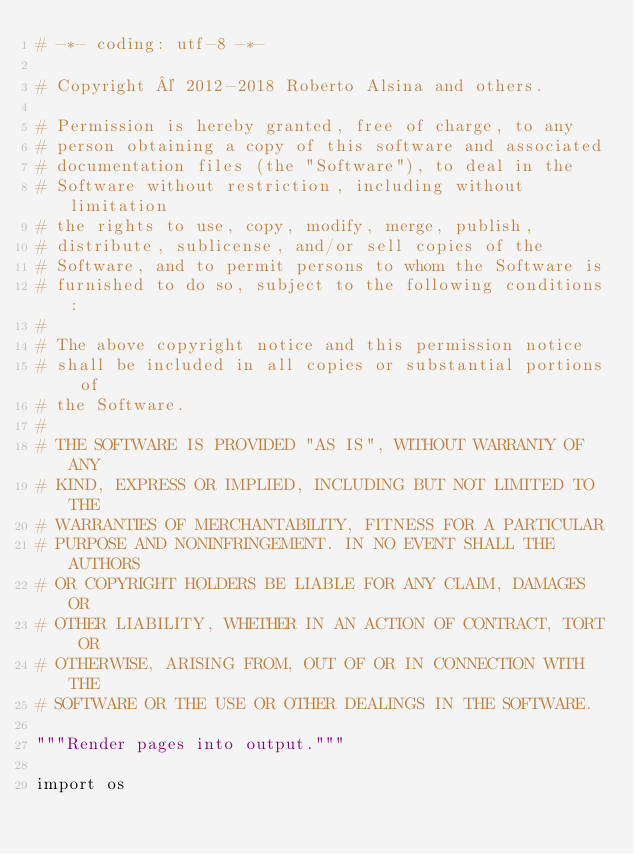<code> <loc_0><loc_0><loc_500><loc_500><_Python_># -*- coding: utf-8 -*-

# Copyright © 2012-2018 Roberto Alsina and others.

# Permission is hereby granted, free of charge, to any
# person obtaining a copy of this software and associated
# documentation files (the "Software"), to deal in the
# Software without restriction, including without limitation
# the rights to use, copy, modify, merge, publish,
# distribute, sublicense, and/or sell copies of the
# Software, and to permit persons to whom the Software is
# furnished to do so, subject to the following conditions:
#
# The above copyright notice and this permission notice
# shall be included in all copies or substantial portions of
# the Software.
#
# THE SOFTWARE IS PROVIDED "AS IS", WITHOUT WARRANTY OF ANY
# KIND, EXPRESS OR IMPLIED, INCLUDING BUT NOT LIMITED TO THE
# WARRANTIES OF MERCHANTABILITY, FITNESS FOR A PARTICULAR
# PURPOSE AND NONINFRINGEMENT. IN NO EVENT SHALL THE AUTHORS
# OR COPYRIGHT HOLDERS BE LIABLE FOR ANY CLAIM, DAMAGES OR
# OTHER LIABILITY, WHETHER IN AN ACTION OF CONTRACT, TORT OR
# OTHERWISE, ARISING FROM, OUT OF OR IN CONNECTION WITH THE
# SOFTWARE OR THE USE OR OTHER DEALINGS IN THE SOFTWARE.

"""Render pages into output."""

import os
</code> 